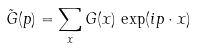<formula> <loc_0><loc_0><loc_500><loc_500>\tilde { G } ( p ) = \sum _ { x } G ( x ) \, \exp ( i p \cdot x )</formula> 